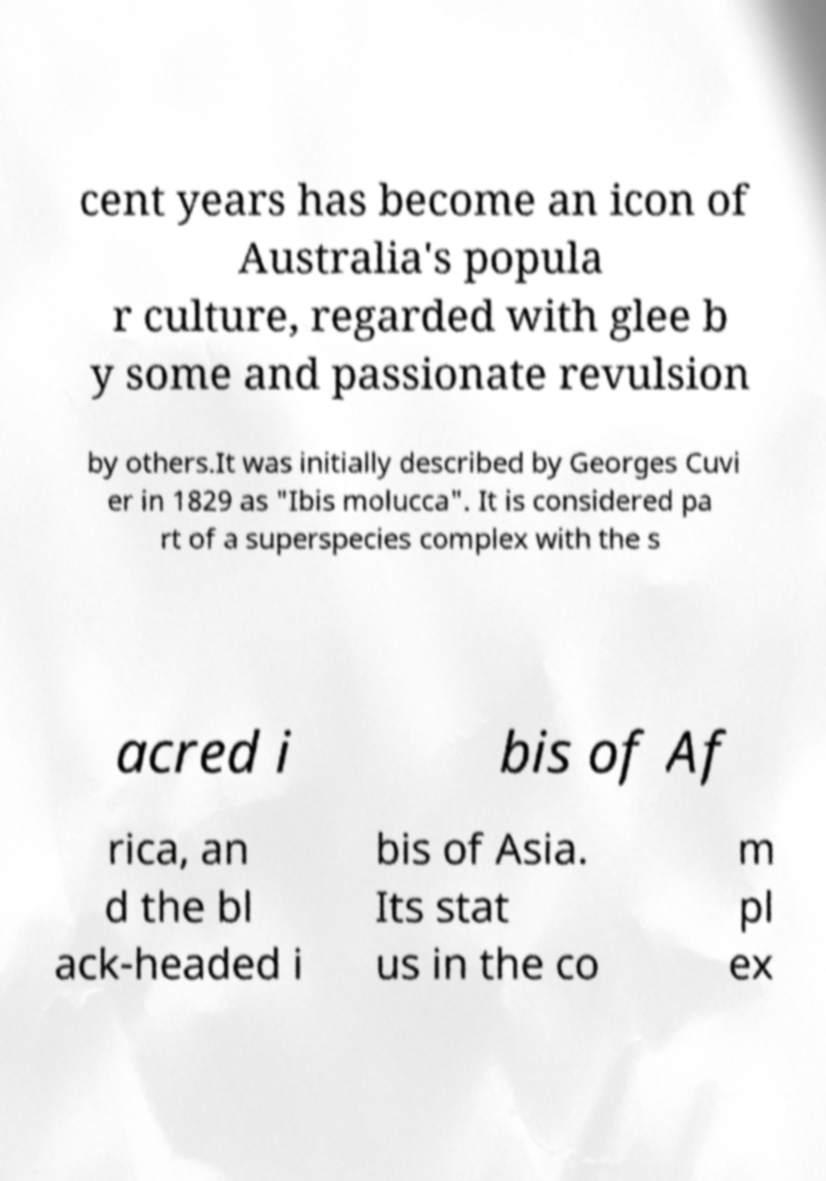What messages or text are displayed in this image? I need them in a readable, typed format. cent years has become an icon of Australia's popula r culture, regarded with glee b y some and passionate revulsion by others.It was initially described by Georges Cuvi er in 1829 as "Ibis molucca". It is considered pa rt of a superspecies complex with the s acred i bis of Af rica, an d the bl ack-headed i bis of Asia. Its stat us in the co m pl ex 